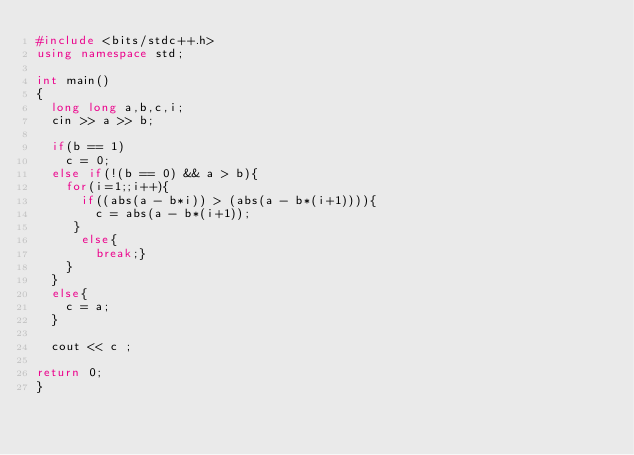Convert code to text. <code><loc_0><loc_0><loc_500><loc_500><_C++_>#include <bits/stdc++.h>
using namespace std;
 
int main()
{
  long long a,b,c,i;
  cin >> a >> b;
  
  if(b == 1)
    c = 0;
  else if(!(b == 0) && a > b){
    for(i=1;;i++){
      if((abs(a - b*i)) > (abs(a - b*(i+1)))){
        c = abs(a - b*(i+1));
     }
      else{
        break;}
    }
  }
  else{
    c = a;
  }
  
  cout << c ;
 
return 0;
}</code> 